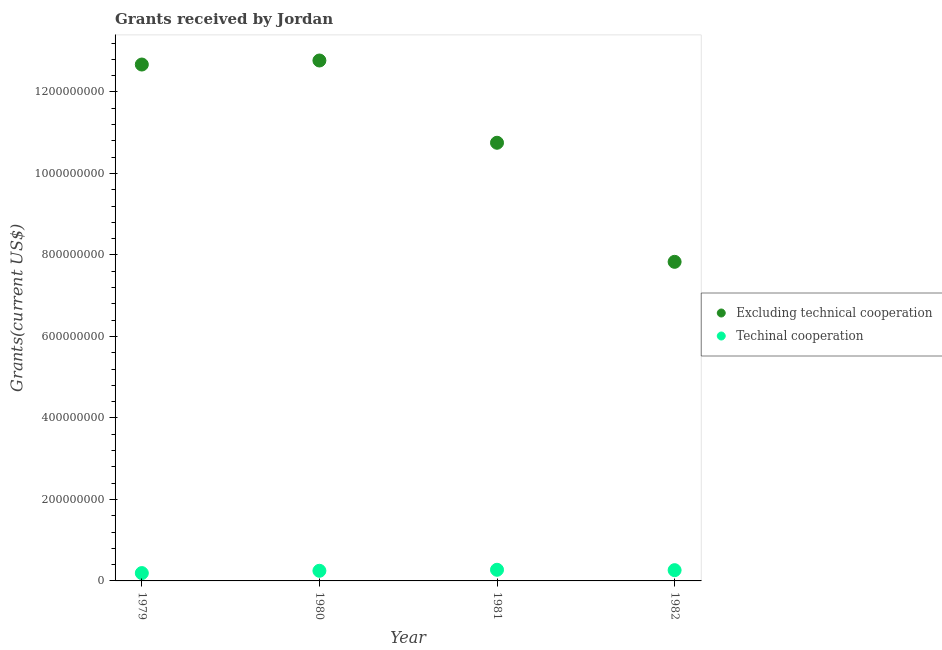Is the number of dotlines equal to the number of legend labels?
Provide a succinct answer. Yes. What is the amount of grants received(excluding technical cooperation) in 1982?
Provide a short and direct response. 7.83e+08. Across all years, what is the maximum amount of grants received(including technical cooperation)?
Make the answer very short. 2.73e+07. Across all years, what is the minimum amount of grants received(excluding technical cooperation)?
Give a very brief answer. 7.83e+08. What is the total amount of grants received(excluding technical cooperation) in the graph?
Keep it short and to the point. 4.40e+09. What is the difference between the amount of grants received(including technical cooperation) in 1979 and that in 1980?
Keep it short and to the point. -5.64e+06. What is the difference between the amount of grants received(including technical cooperation) in 1979 and the amount of grants received(excluding technical cooperation) in 1980?
Provide a succinct answer. -1.26e+09. What is the average amount of grants received(excluding technical cooperation) per year?
Provide a short and direct response. 1.10e+09. In the year 1981, what is the difference between the amount of grants received(including technical cooperation) and amount of grants received(excluding technical cooperation)?
Your response must be concise. -1.05e+09. In how many years, is the amount of grants received(excluding technical cooperation) greater than 520000000 US$?
Offer a very short reply. 4. What is the ratio of the amount of grants received(excluding technical cooperation) in 1980 to that in 1982?
Offer a terse response. 1.63. Is the difference between the amount of grants received(including technical cooperation) in 1980 and 1982 greater than the difference between the amount of grants received(excluding technical cooperation) in 1980 and 1982?
Keep it short and to the point. No. What is the difference between the highest and the second highest amount of grants received(excluding technical cooperation)?
Ensure brevity in your answer.  9.88e+06. What is the difference between the highest and the lowest amount of grants received(including technical cooperation)?
Offer a very short reply. 8.10e+06. In how many years, is the amount of grants received(including technical cooperation) greater than the average amount of grants received(including technical cooperation) taken over all years?
Keep it short and to the point. 3. Does the amount of grants received(excluding technical cooperation) monotonically increase over the years?
Give a very brief answer. No. Is the amount of grants received(including technical cooperation) strictly greater than the amount of grants received(excluding technical cooperation) over the years?
Offer a terse response. No. Is the amount of grants received(including technical cooperation) strictly less than the amount of grants received(excluding technical cooperation) over the years?
Provide a short and direct response. Yes. How many dotlines are there?
Your response must be concise. 2. What is the difference between two consecutive major ticks on the Y-axis?
Offer a terse response. 2.00e+08. Does the graph contain any zero values?
Offer a very short reply. No. Does the graph contain grids?
Offer a terse response. No. Where does the legend appear in the graph?
Provide a short and direct response. Center right. How many legend labels are there?
Provide a succinct answer. 2. What is the title of the graph?
Make the answer very short. Grants received by Jordan. What is the label or title of the X-axis?
Your answer should be compact. Year. What is the label or title of the Y-axis?
Keep it short and to the point. Grants(current US$). What is the Grants(current US$) of Excluding technical cooperation in 1979?
Give a very brief answer. 1.27e+09. What is the Grants(current US$) in Techinal cooperation in 1979?
Provide a short and direct response. 1.92e+07. What is the Grants(current US$) in Excluding technical cooperation in 1980?
Give a very brief answer. 1.28e+09. What is the Grants(current US$) in Techinal cooperation in 1980?
Provide a short and direct response. 2.49e+07. What is the Grants(current US$) of Excluding technical cooperation in 1981?
Provide a succinct answer. 1.08e+09. What is the Grants(current US$) in Techinal cooperation in 1981?
Your answer should be compact. 2.73e+07. What is the Grants(current US$) in Excluding technical cooperation in 1982?
Offer a terse response. 7.83e+08. What is the Grants(current US$) of Techinal cooperation in 1982?
Keep it short and to the point. 2.64e+07. Across all years, what is the maximum Grants(current US$) of Excluding technical cooperation?
Keep it short and to the point. 1.28e+09. Across all years, what is the maximum Grants(current US$) in Techinal cooperation?
Your response must be concise. 2.73e+07. Across all years, what is the minimum Grants(current US$) of Excluding technical cooperation?
Ensure brevity in your answer.  7.83e+08. Across all years, what is the minimum Grants(current US$) of Techinal cooperation?
Ensure brevity in your answer.  1.92e+07. What is the total Grants(current US$) of Excluding technical cooperation in the graph?
Provide a succinct answer. 4.40e+09. What is the total Grants(current US$) in Techinal cooperation in the graph?
Keep it short and to the point. 9.79e+07. What is the difference between the Grants(current US$) of Excluding technical cooperation in 1979 and that in 1980?
Ensure brevity in your answer.  -9.88e+06. What is the difference between the Grants(current US$) of Techinal cooperation in 1979 and that in 1980?
Your response must be concise. -5.64e+06. What is the difference between the Grants(current US$) of Excluding technical cooperation in 1979 and that in 1981?
Provide a succinct answer. 1.92e+08. What is the difference between the Grants(current US$) in Techinal cooperation in 1979 and that in 1981?
Offer a terse response. -8.10e+06. What is the difference between the Grants(current US$) of Excluding technical cooperation in 1979 and that in 1982?
Ensure brevity in your answer.  4.84e+08. What is the difference between the Grants(current US$) in Techinal cooperation in 1979 and that in 1982?
Keep it short and to the point. -7.17e+06. What is the difference between the Grants(current US$) of Excluding technical cooperation in 1980 and that in 1981?
Make the answer very short. 2.02e+08. What is the difference between the Grants(current US$) of Techinal cooperation in 1980 and that in 1981?
Your answer should be very brief. -2.46e+06. What is the difference between the Grants(current US$) of Excluding technical cooperation in 1980 and that in 1982?
Offer a very short reply. 4.94e+08. What is the difference between the Grants(current US$) in Techinal cooperation in 1980 and that in 1982?
Your answer should be compact. -1.53e+06. What is the difference between the Grants(current US$) in Excluding technical cooperation in 1981 and that in 1982?
Your answer should be very brief. 2.92e+08. What is the difference between the Grants(current US$) of Techinal cooperation in 1981 and that in 1982?
Give a very brief answer. 9.30e+05. What is the difference between the Grants(current US$) of Excluding technical cooperation in 1979 and the Grants(current US$) of Techinal cooperation in 1980?
Provide a short and direct response. 1.24e+09. What is the difference between the Grants(current US$) in Excluding technical cooperation in 1979 and the Grants(current US$) in Techinal cooperation in 1981?
Ensure brevity in your answer.  1.24e+09. What is the difference between the Grants(current US$) of Excluding technical cooperation in 1979 and the Grants(current US$) of Techinal cooperation in 1982?
Your answer should be very brief. 1.24e+09. What is the difference between the Grants(current US$) in Excluding technical cooperation in 1980 and the Grants(current US$) in Techinal cooperation in 1981?
Provide a succinct answer. 1.25e+09. What is the difference between the Grants(current US$) in Excluding technical cooperation in 1980 and the Grants(current US$) in Techinal cooperation in 1982?
Provide a succinct answer. 1.25e+09. What is the difference between the Grants(current US$) of Excluding technical cooperation in 1981 and the Grants(current US$) of Techinal cooperation in 1982?
Ensure brevity in your answer.  1.05e+09. What is the average Grants(current US$) in Excluding technical cooperation per year?
Offer a very short reply. 1.10e+09. What is the average Grants(current US$) in Techinal cooperation per year?
Your answer should be very brief. 2.45e+07. In the year 1979, what is the difference between the Grants(current US$) in Excluding technical cooperation and Grants(current US$) in Techinal cooperation?
Offer a very short reply. 1.25e+09. In the year 1980, what is the difference between the Grants(current US$) of Excluding technical cooperation and Grants(current US$) of Techinal cooperation?
Ensure brevity in your answer.  1.25e+09. In the year 1981, what is the difference between the Grants(current US$) in Excluding technical cooperation and Grants(current US$) in Techinal cooperation?
Provide a succinct answer. 1.05e+09. In the year 1982, what is the difference between the Grants(current US$) of Excluding technical cooperation and Grants(current US$) of Techinal cooperation?
Your answer should be very brief. 7.57e+08. What is the ratio of the Grants(current US$) of Techinal cooperation in 1979 to that in 1980?
Ensure brevity in your answer.  0.77. What is the ratio of the Grants(current US$) of Excluding technical cooperation in 1979 to that in 1981?
Provide a short and direct response. 1.18. What is the ratio of the Grants(current US$) of Techinal cooperation in 1979 to that in 1981?
Provide a succinct answer. 0.7. What is the ratio of the Grants(current US$) of Excluding technical cooperation in 1979 to that in 1982?
Your response must be concise. 1.62. What is the ratio of the Grants(current US$) in Techinal cooperation in 1979 to that in 1982?
Ensure brevity in your answer.  0.73. What is the ratio of the Grants(current US$) in Excluding technical cooperation in 1980 to that in 1981?
Make the answer very short. 1.19. What is the ratio of the Grants(current US$) of Techinal cooperation in 1980 to that in 1981?
Provide a short and direct response. 0.91. What is the ratio of the Grants(current US$) in Excluding technical cooperation in 1980 to that in 1982?
Give a very brief answer. 1.63. What is the ratio of the Grants(current US$) in Techinal cooperation in 1980 to that in 1982?
Provide a short and direct response. 0.94. What is the ratio of the Grants(current US$) in Excluding technical cooperation in 1981 to that in 1982?
Make the answer very short. 1.37. What is the ratio of the Grants(current US$) in Techinal cooperation in 1981 to that in 1982?
Your response must be concise. 1.04. What is the difference between the highest and the second highest Grants(current US$) in Excluding technical cooperation?
Offer a very short reply. 9.88e+06. What is the difference between the highest and the second highest Grants(current US$) of Techinal cooperation?
Provide a short and direct response. 9.30e+05. What is the difference between the highest and the lowest Grants(current US$) of Excluding technical cooperation?
Provide a succinct answer. 4.94e+08. What is the difference between the highest and the lowest Grants(current US$) in Techinal cooperation?
Your answer should be compact. 8.10e+06. 